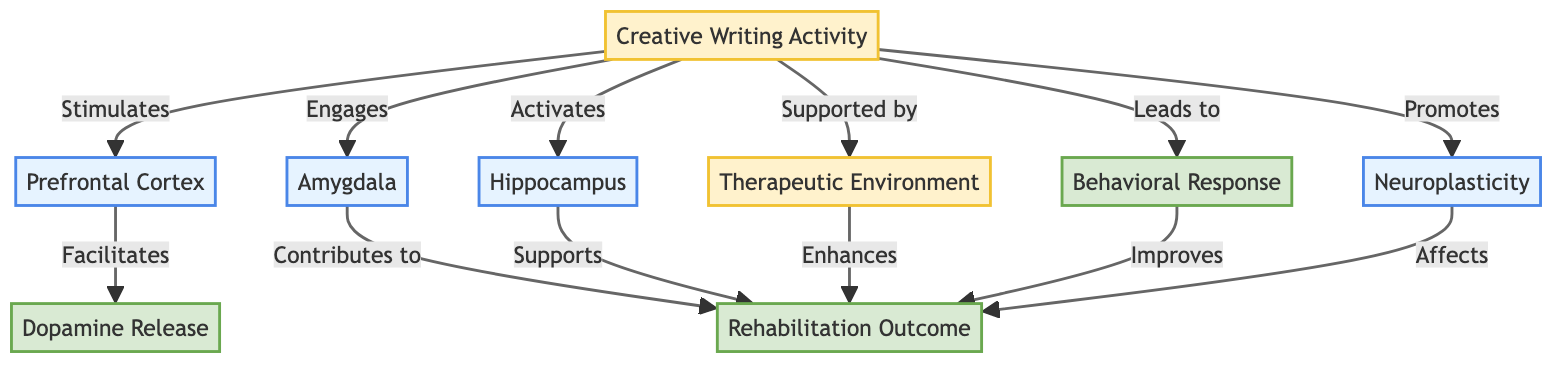What are the main brain areas involved in the diagram? The diagram identifies three main brain areas involved: Prefrontal Cortex, Amygdala, and Hippocampus. These are the nodes representing the response of the brain in the context of creative writing activities.
Answer: Prefrontal Cortex, Amygdala, Hippocampus How many activity nodes are present in the diagram? There are three activity nodes in the diagram: Creative Writing Activity, Therapeutic Environment, and Behavioral Response. By counting the boxes labeled as activities, the total is established.
Answer: 3 Which activity stimulates the Prefrontal Cortex? The Creative Writing Activity stimulates the Prefrontal Cortex, as indicated by the direct connection from the Creative Writing Activity node to the Prefrontal Cortex node, marked with the word "Stimulates."
Answer: Creative Writing Activity What is the outcome of engaging the Amygdala? Engaging the Amygdala contributes to the Rehabilitation Outcome, as shown by the link flowing from the Amygdala node to the Rehabilitation Outcome node, which specifies "Contributes to."
Answer: Rehabilitation Outcome How does the Therapeutic Environment affect rehabilitation? The Therapeutic Environment enhances the Rehabilitation Outcome, as highlighted by the arrow linking the Therapeutic Environment to the Rehabilitation Outcome, marked with "Enhances." Hence, it shows how a supportive environment plays a role in rehabilitation.
Answer: Enhances Which brain area is associated with neuroplasticity? Neuroplasticity in the diagram is represented as the result of the Creative Writing Activity's promotion, connecting directly to the Neuroplasticity node. Thus, the corresponding brain area here promotes the potential for change in the brain.
Answer: Neuroplasticity What leads to an improved Rehabilitation Outcome? The diagram indicates that several factors lead to an improved Rehabilitation Outcome, including the Behavioral Response and the enhancements from the Therapeutic Environment and neuroplasticity induced by the Creative Writing Activity. Each of these facets highlights aspects that determine effectiveness in rehabilitation.
Answer: Behavioral Response, Therapeutic Environment, Neuroplasticity 